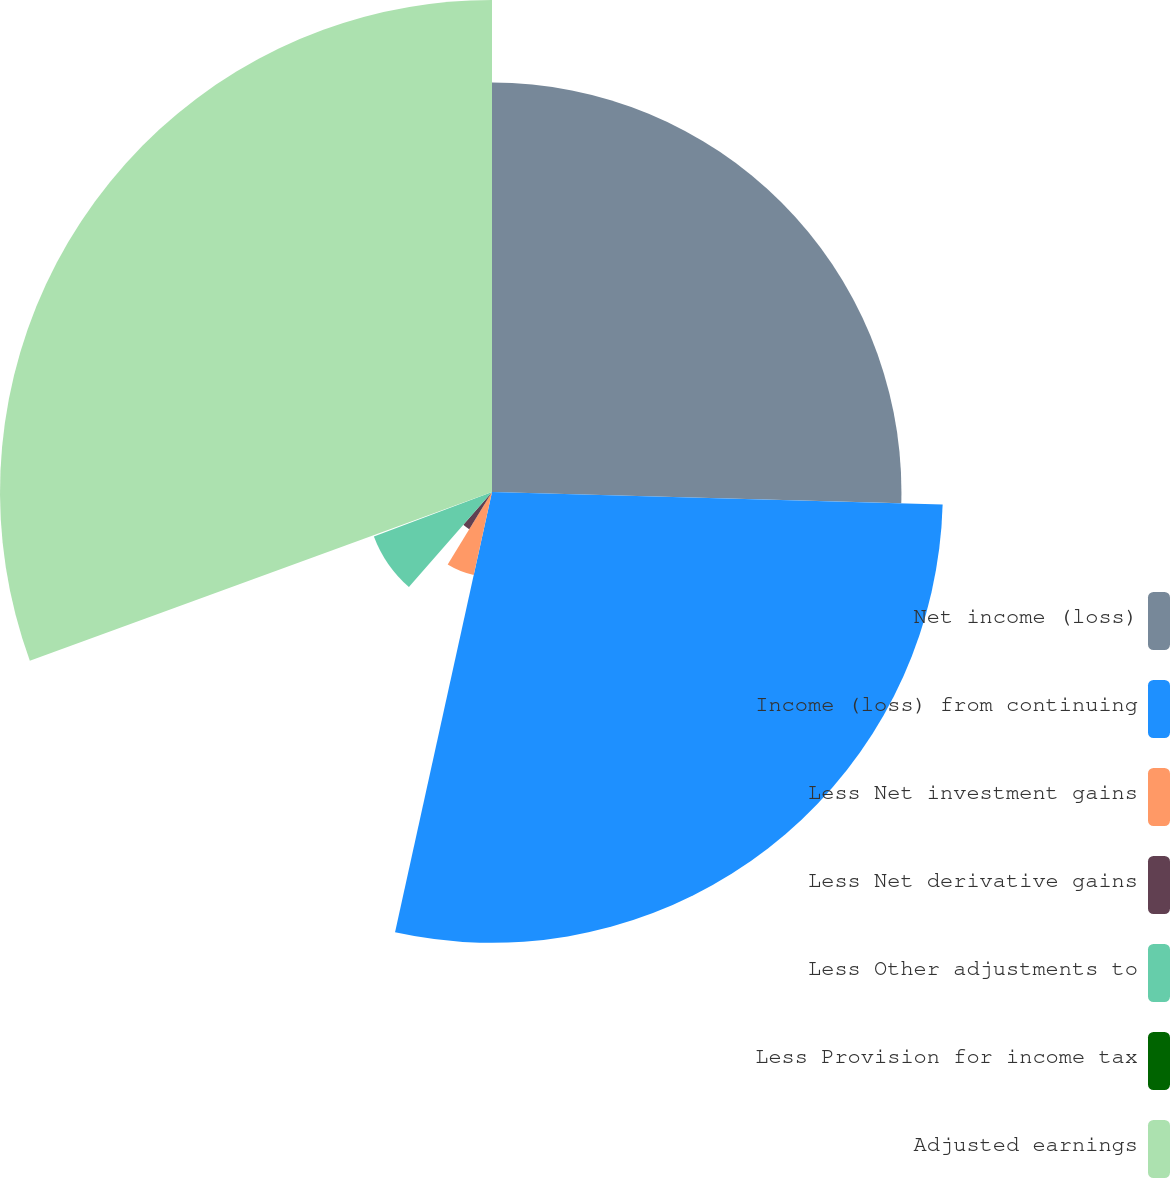Convert chart to OTSL. <chart><loc_0><loc_0><loc_500><loc_500><pie_chart><fcel>Net income (loss)<fcel>Income (loss) from continuing<fcel>Less Net investment gains<fcel>Less Net derivative gains<fcel>Less Other adjustments to<fcel>Less Provision for income tax<fcel>Adjusted earnings<nl><fcel>25.44%<fcel>28.01%<fcel>5.28%<fcel>2.71%<fcel>7.84%<fcel>0.15%<fcel>30.57%<nl></chart> 